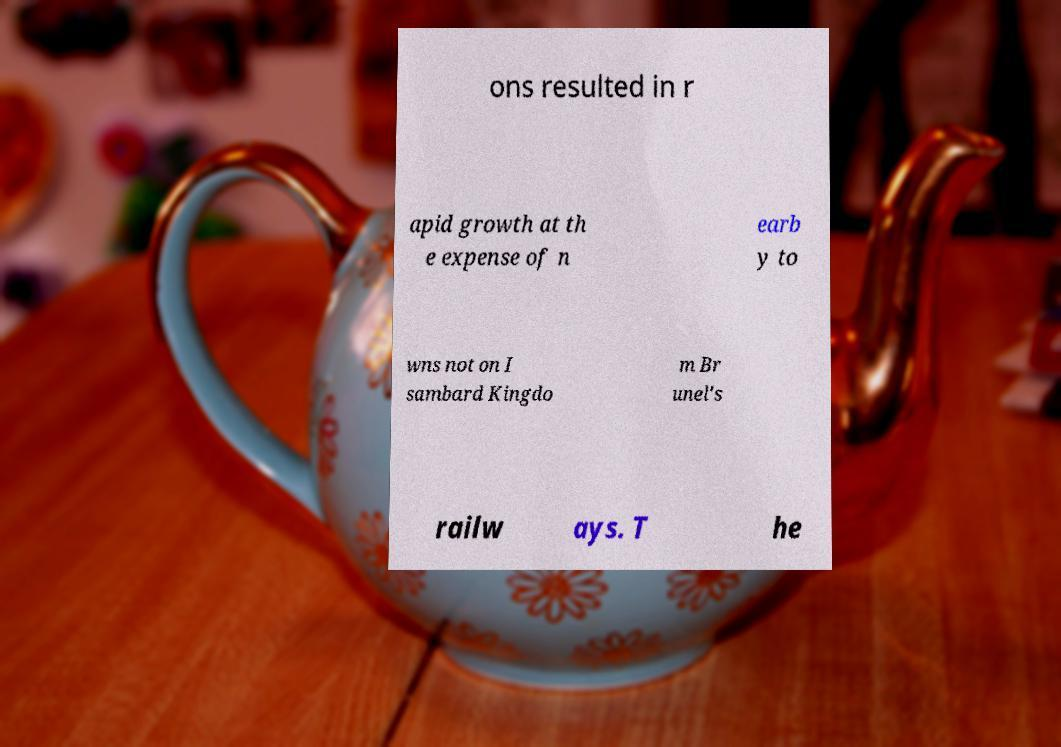Could you assist in decoding the text presented in this image and type it out clearly? ons resulted in r apid growth at th e expense of n earb y to wns not on I sambard Kingdo m Br unel's railw ays. T he 